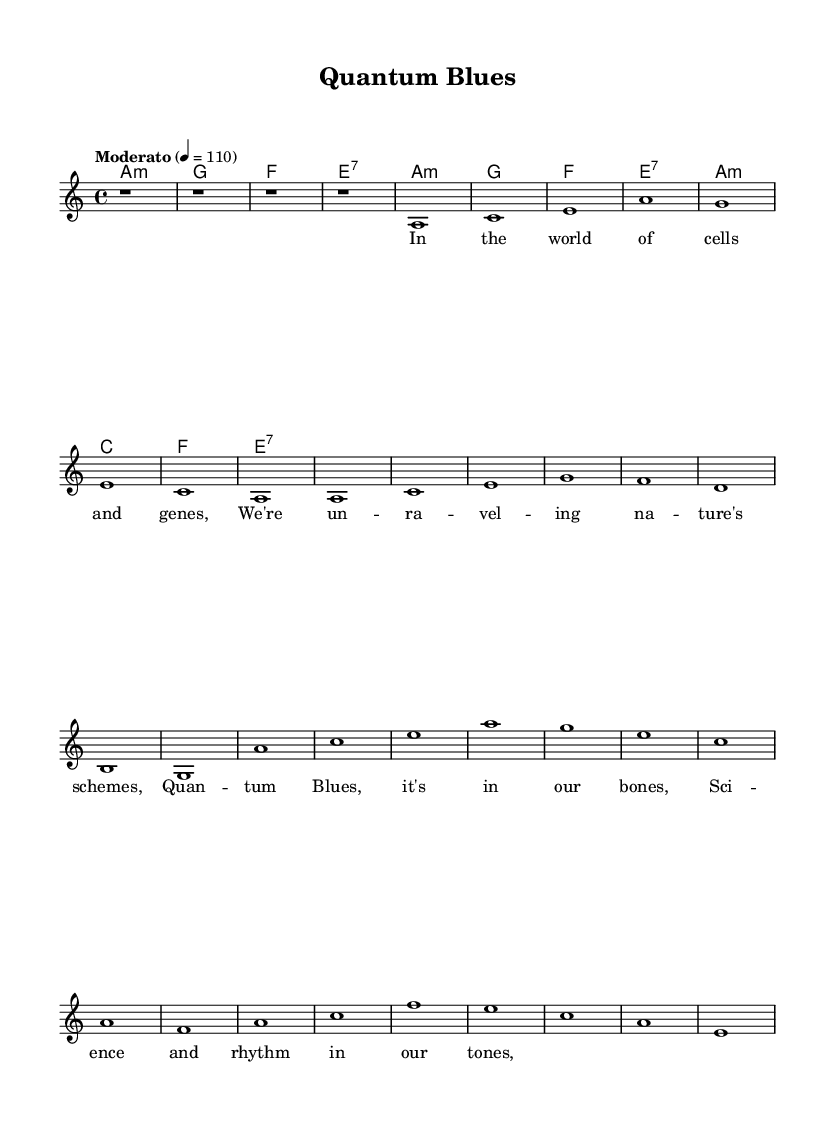What is the key signature of this music? The key signature is A minor, which has no sharps or flats, as indicated at the beginning of the score.
Answer: A minor What is the time signature of this music? The time signature is 4/4, which means there are four beats per measure, as denoted in the upper left corner of the sheet music.
Answer: 4/4 What is the tempo marking of this piece? The tempo marking is "Moderato" with a metronome marking of 110 beats per minute, shown at the start of the global section.
Answer: Moderato 110 How many measures are in the verse? The verse consists of four measures as indicated by the structure of the melody and lyrics, which only appears once before the chorus.
Answer: Four What type of chords are primarily used in this piece? The chords used in this piece are primarily minor and seventh chords, as reflected in the chord names: A minor, G major, F major, and E seventh.
Answer: Minor and seventh What is the primary thematic inspiration for the lyrics? The lyrics are inspired by scientific discoveries related to cells and genes, clearly mentioned in the verse.
Answer: Scientific discoveries What lyric motif is repeated in the chorus? The lyric motif that is repeated in the chorus is the concept of "Quantum Blues," which is a central theme of the song.
Answer: Quantum Blues 